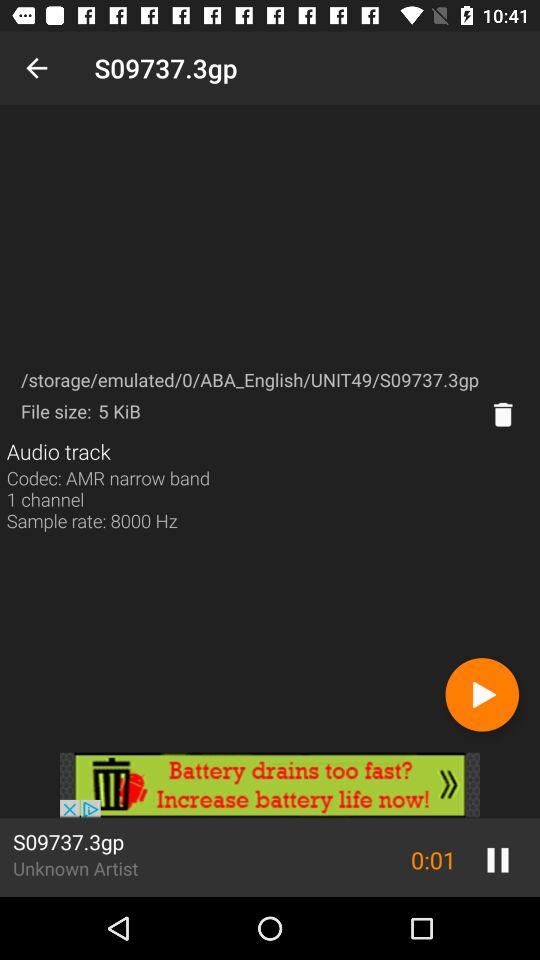For how long has the track been played? The track has been played for 1 second. 